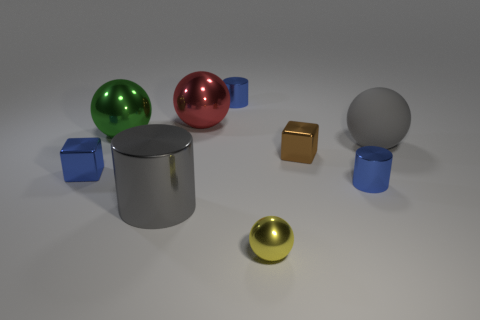Is the big gray ball made of the same material as the red sphere?
Give a very brief answer. No. There is a brown object in front of the big rubber sphere; what is its shape?
Provide a succinct answer. Cube. Are there any small blue metal things that are left of the big gray cylinder that is on the right side of the large green object?
Keep it short and to the point. Yes. Is there a gray metal cylinder that has the same size as the gray matte object?
Offer a very short reply. Yes. There is a ball that is in front of the large matte object; is its color the same as the big cylinder?
Make the answer very short. No. The brown block has what size?
Give a very brief answer. Small. What size is the blue thing that is in front of the metal cube that is left of the big green ball?
Provide a succinct answer. Small. What number of shiny cubes are the same color as the tiny shiny sphere?
Offer a terse response. 0. How many red rubber cylinders are there?
Give a very brief answer. 0. How many brown things are the same material as the gray sphere?
Offer a very short reply. 0. 